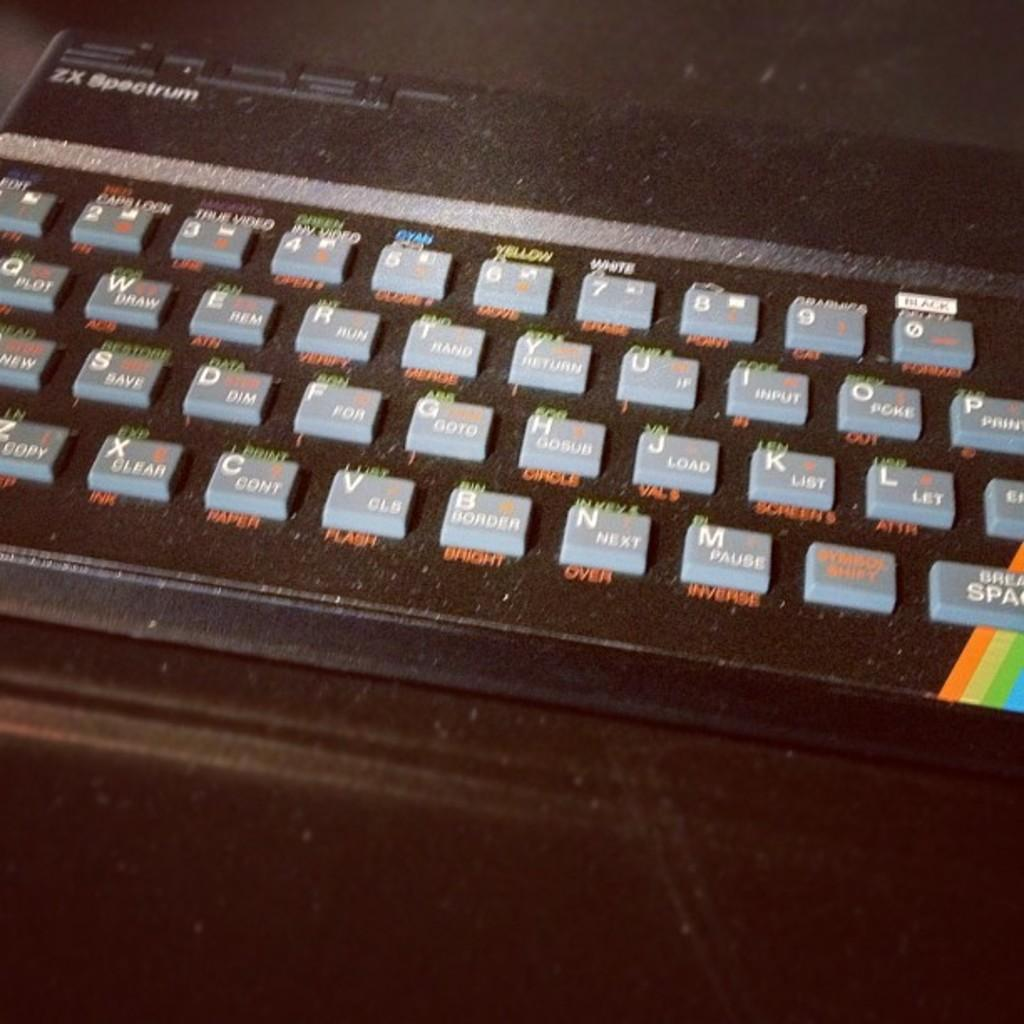<image>
Present a compact description of the photo's key features. A black ZX Spectrum black keyboard with grey keys. 